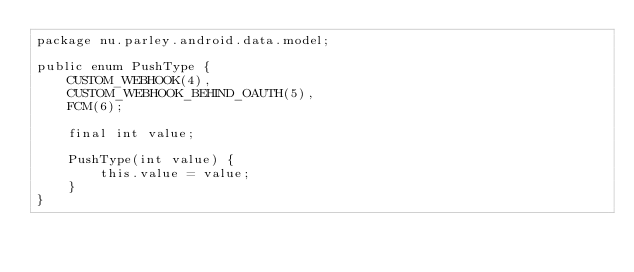Convert code to text. <code><loc_0><loc_0><loc_500><loc_500><_Java_>package nu.parley.android.data.model;

public enum PushType {
    CUSTOM_WEBHOOK(4),
    CUSTOM_WEBHOOK_BEHIND_OAUTH(5),
    FCM(6);

    final int value;

    PushType(int value) {
        this.value = value;
    }
}
</code> 